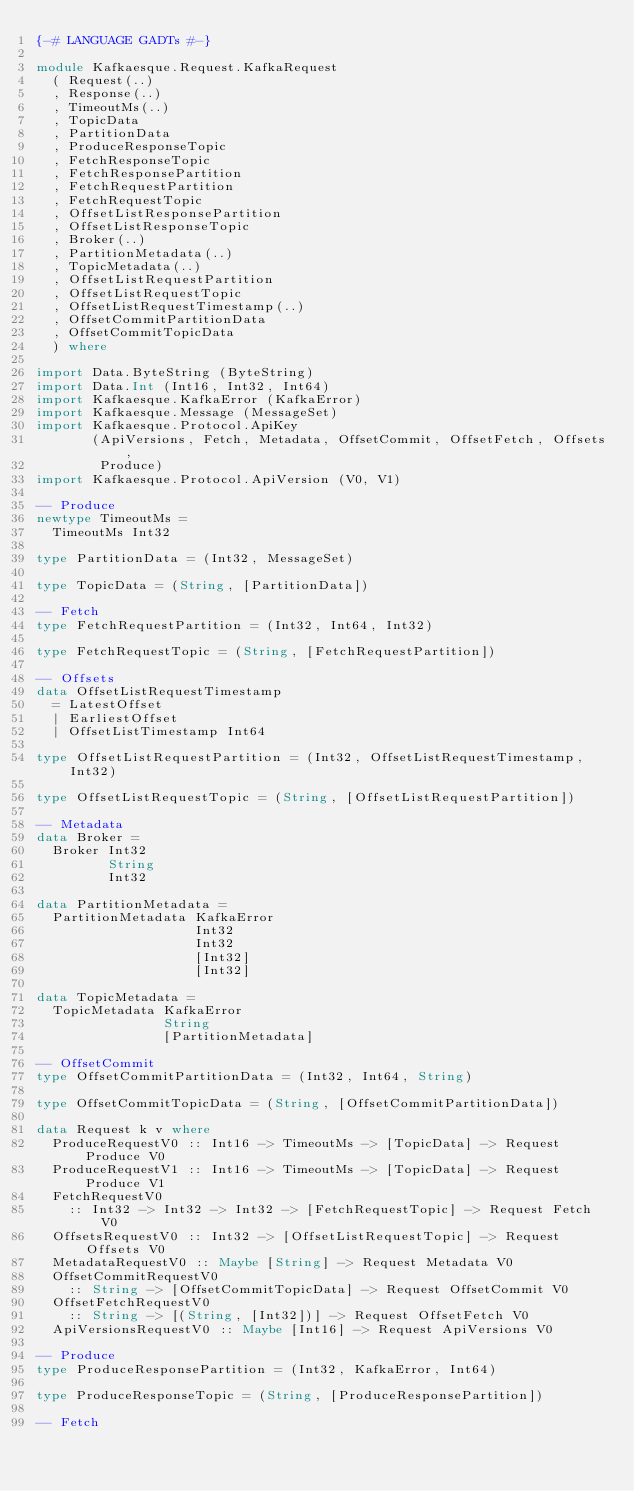Convert code to text. <code><loc_0><loc_0><loc_500><loc_500><_Haskell_>{-# LANGUAGE GADTs #-}

module Kafkaesque.Request.KafkaRequest
  ( Request(..)
  , Response(..)
  , TimeoutMs(..)
  , TopicData
  , PartitionData
  , ProduceResponseTopic
  , FetchResponseTopic
  , FetchResponsePartition
  , FetchRequestPartition
  , FetchRequestTopic
  , OffsetListResponsePartition
  , OffsetListResponseTopic
  , Broker(..)
  , PartitionMetadata(..)
  , TopicMetadata(..)
  , OffsetListRequestPartition
  , OffsetListRequestTopic
  , OffsetListRequestTimestamp(..)
  , OffsetCommitPartitionData
  , OffsetCommitTopicData
  ) where

import Data.ByteString (ByteString)
import Data.Int (Int16, Int32, Int64)
import Kafkaesque.KafkaError (KafkaError)
import Kafkaesque.Message (MessageSet)
import Kafkaesque.Protocol.ApiKey
       (ApiVersions, Fetch, Metadata, OffsetCommit, OffsetFetch, Offsets,
        Produce)
import Kafkaesque.Protocol.ApiVersion (V0, V1)

-- Produce
newtype TimeoutMs =
  TimeoutMs Int32

type PartitionData = (Int32, MessageSet)

type TopicData = (String, [PartitionData])

-- Fetch
type FetchRequestPartition = (Int32, Int64, Int32)

type FetchRequestTopic = (String, [FetchRequestPartition])

-- Offsets
data OffsetListRequestTimestamp
  = LatestOffset
  | EarliestOffset
  | OffsetListTimestamp Int64

type OffsetListRequestPartition = (Int32, OffsetListRequestTimestamp, Int32)

type OffsetListRequestTopic = (String, [OffsetListRequestPartition])

-- Metadata
data Broker =
  Broker Int32
         String
         Int32

data PartitionMetadata =
  PartitionMetadata KafkaError
                    Int32
                    Int32
                    [Int32]
                    [Int32]

data TopicMetadata =
  TopicMetadata KafkaError
                String
                [PartitionMetadata]

-- OffsetCommit
type OffsetCommitPartitionData = (Int32, Int64, String)

type OffsetCommitTopicData = (String, [OffsetCommitPartitionData])

data Request k v where
  ProduceRequestV0 :: Int16 -> TimeoutMs -> [TopicData] -> Request Produce V0
  ProduceRequestV1 :: Int16 -> TimeoutMs -> [TopicData] -> Request Produce V1
  FetchRequestV0
    :: Int32 -> Int32 -> Int32 -> [FetchRequestTopic] -> Request Fetch V0
  OffsetsRequestV0 :: Int32 -> [OffsetListRequestTopic] -> Request Offsets V0
  MetadataRequestV0 :: Maybe [String] -> Request Metadata V0
  OffsetCommitRequestV0
    :: String -> [OffsetCommitTopicData] -> Request OffsetCommit V0
  OffsetFetchRequestV0
    :: String -> [(String, [Int32])] -> Request OffsetFetch V0
  ApiVersionsRequestV0 :: Maybe [Int16] -> Request ApiVersions V0

-- Produce
type ProduceResponsePartition = (Int32, KafkaError, Int64)

type ProduceResponseTopic = (String, [ProduceResponsePartition])

-- Fetch</code> 